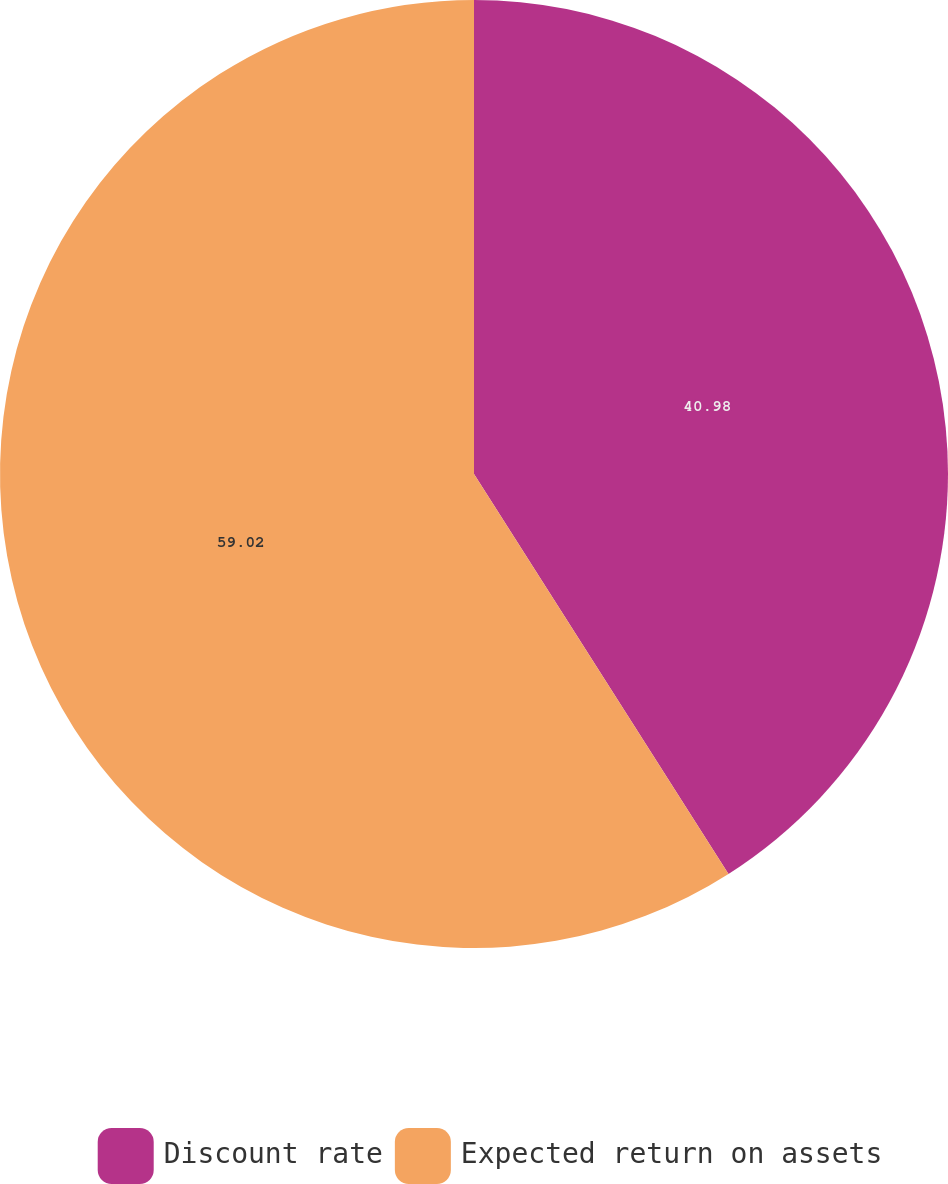<chart> <loc_0><loc_0><loc_500><loc_500><pie_chart><fcel>Discount rate<fcel>Expected return on assets<nl><fcel>40.98%<fcel>59.02%<nl></chart> 